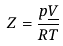<formula> <loc_0><loc_0><loc_500><loc_500>Z = { \frac { p { \underline { V } } } { R T } }</formula> 